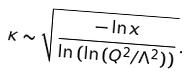Convert formula to latex. <formula><loc_0><loc_0><loc_500><loc_500>\kappa \sim \sqrt { \frac { - \ln { x } } { \ln { ( \ln { ( Q ^ { 2 } / \Lambda ^ { 2 } ) } ) } } } \, .</formula> 